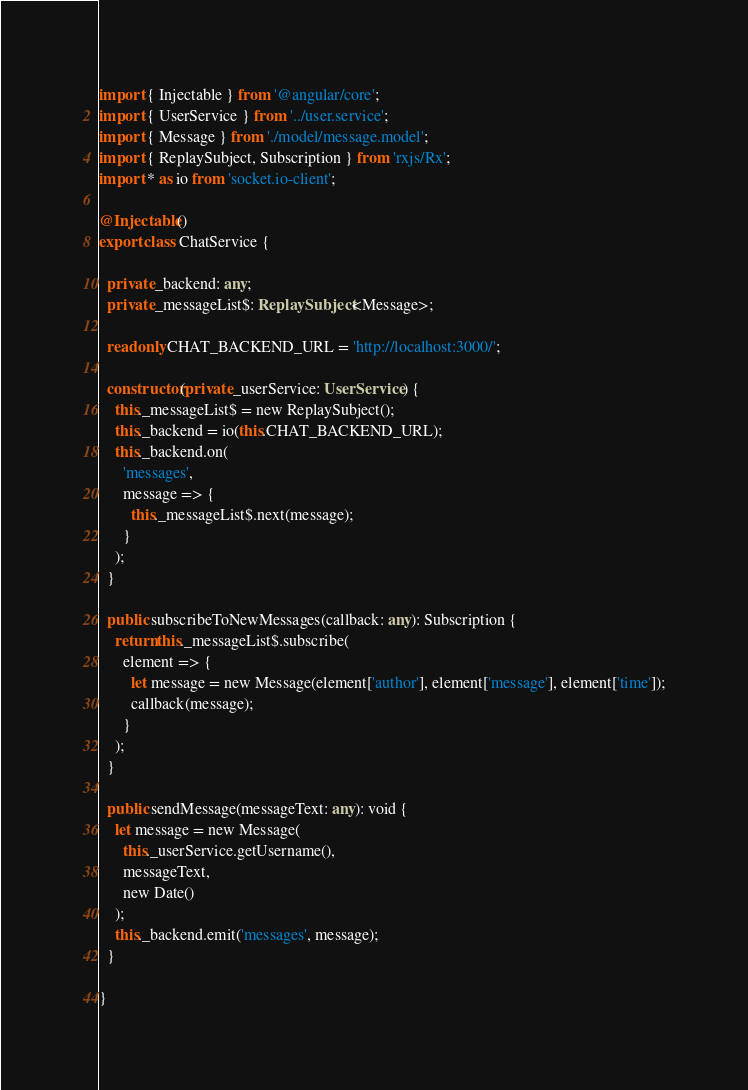<code> <loc_0><loc_0><loc_500><loc_500><_TypeScript_>import { Injectable } from '@angular/core';
import { UserService } from '../user.service';
import { Message } from './model/message.model';
import { ReplaySubject, Subscription } from 'rxjs/Rx';
import * as io from 'socket.io-client';

@Injectable()
export class ChatService {

  private _backend: any;
  private _messageList$: ReplaySubject<Message>;

  readonly CHAT_BACKEND_URL = 'http://localhost:3000/';

  constructor(private _userService: UserService) {
    this._messageList$ = new ReplaySubject();
    this._backend = io(this.CHAT_BACKEND_URL);
    this._backend.on(
      'messages',
      message => {
        this._messageList$.next(message);
      }
    );
  }

  public subscribeToNewMessages(callback: any): Subscription {
    return this._messageList$.subscribe(
      element => {
        let message = new Message(element['author'], element['message'], element['time']);
        callback(message);
      }
    );
  }

  public sendMessage(messageText: any): void {
    let message = new Message(
      this._userService.getUsername(),
      messageText,
      new Date()
    );
    this._backend.emit('messages', message);
  }

}
</code> 